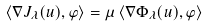<formula> <loc_0><loc_0><loc_500><loc_500>\left \langle \nabla J _ { \lambda } ( u ) , \varphi \right \rangle = \mu \left \langle \nabla \Phi _ { \lambda } ( u ) , \varphi \right \rangle</formula> 